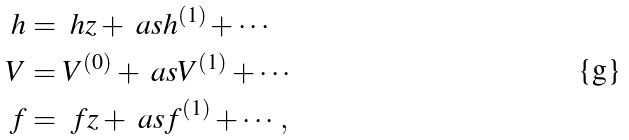Convert formula to latex. <formula><loc_0><loc_0><loc_500><loc_500>h & = \ h z + \ a s h ^ { ( 1 ) } + \cdots \\ V & = V ^ { ( 0 ) } + \ a s V ^ { ( 1 ) } + \cdots \\ f & = \ f z + \ a s f ^ { ( 1 ) } + \cdots \, ,</formula> 